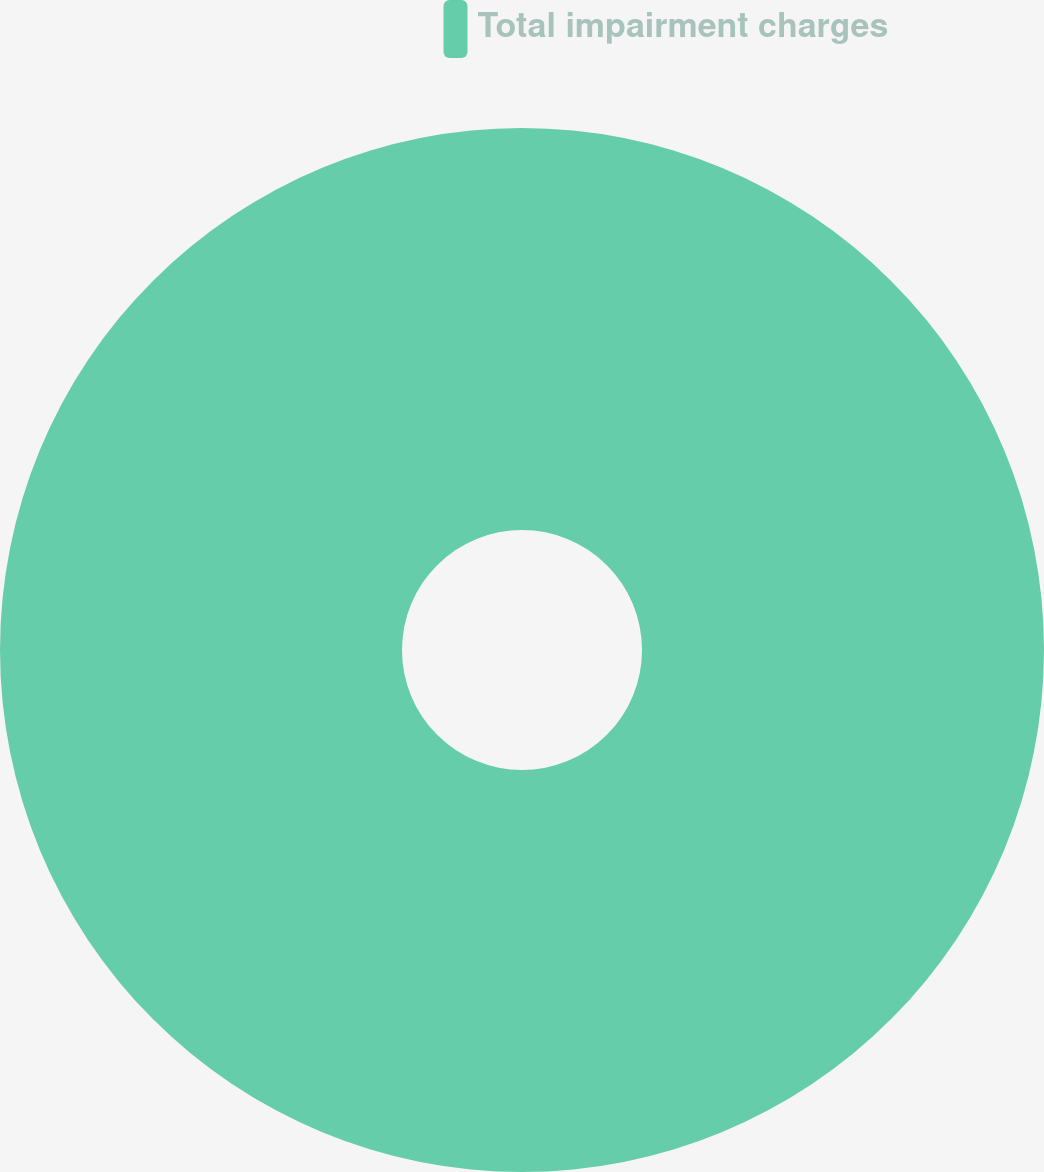Convert chart. <chart><loc_0><loc_0><loc_500><loc_500><pie_chart><fcel>Total impairment charges<nl><fcel>100.0%<nl></chart> 